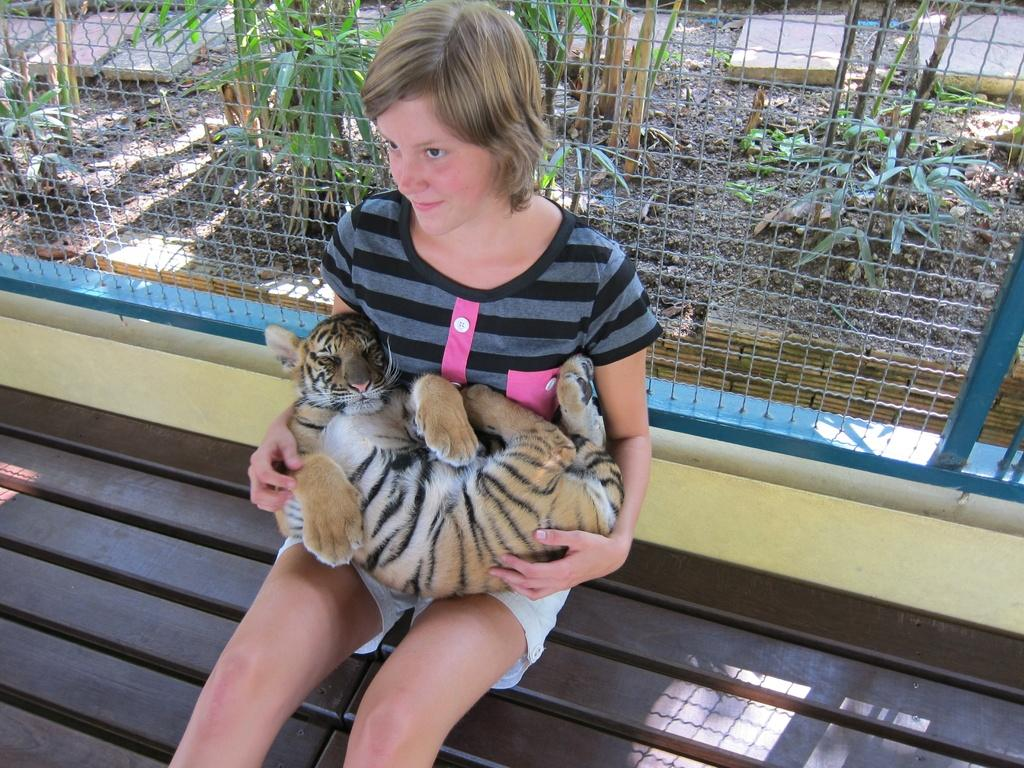What is the girl sitting on in the image? The girl is sitting on a wooden bench. What is the girl holding in her lap? The girl is holding a tiger in her lap. What type of fencing is visible behind the girl? There is an iron fencing behind the girl. What type of chair is visible in the image? There is no chair visible in the image; the girl is sitting on a wooden bench. Is there a door present in the image? There is no door present in the image. 